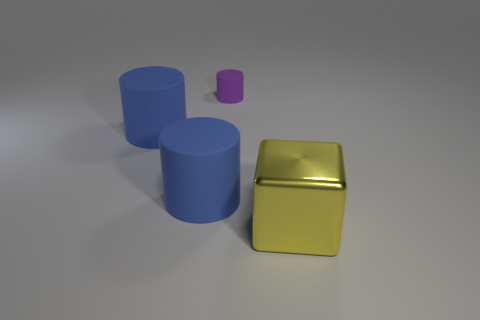Is there anything else that has the same size as the purple cylinder?
Make the answer very short. No. Is there anything else that is the same shape as the large yellow object?
Keep it short and to the point. No. Is there anything else that has the same material as the big yellow cube?
Give a very brief answer. No. What number of big objects are purple rubber cylinders or brown metallic blocks?
Offer a very short reply. 0. There is a object that is right of the purple rubber thing; what shape is it?
Ensure brevity in your answer.  Cube. What number of tiny objects are there?
Make the answer very short. 1. Does the big yellow block have the same material as the small purple thing?
Keep it short and to the point. No. Are there more large blue matte cylinders to the left of the small matte thing than small green metal things?
Give a very brief answer. Yes. How many things are small objects or big objects that are on the left side of the large yellow shiny block?
Offer a terse response. 3. Are there more big blocks in front of the large yellow shiny thing than big rubber objects behind the purple thing?
Your answer should be compact. No. 